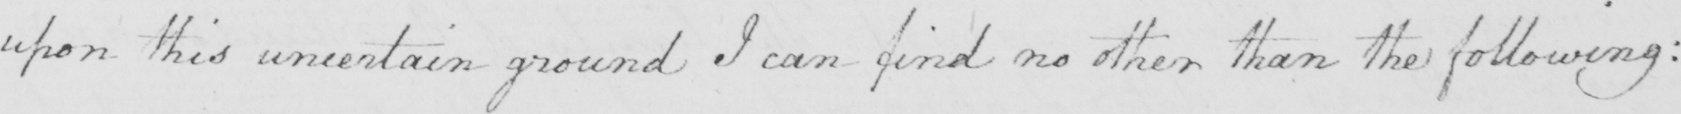Please transcribe the handwritten text in this image. upon this uncertain ground I can find no other than the following : 